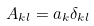Convert formula to latex. <formula><loc_0><loc_0><loc_500><loc_500>A _ { k l } = a _ { k } \delta _ { k l }</formula> 